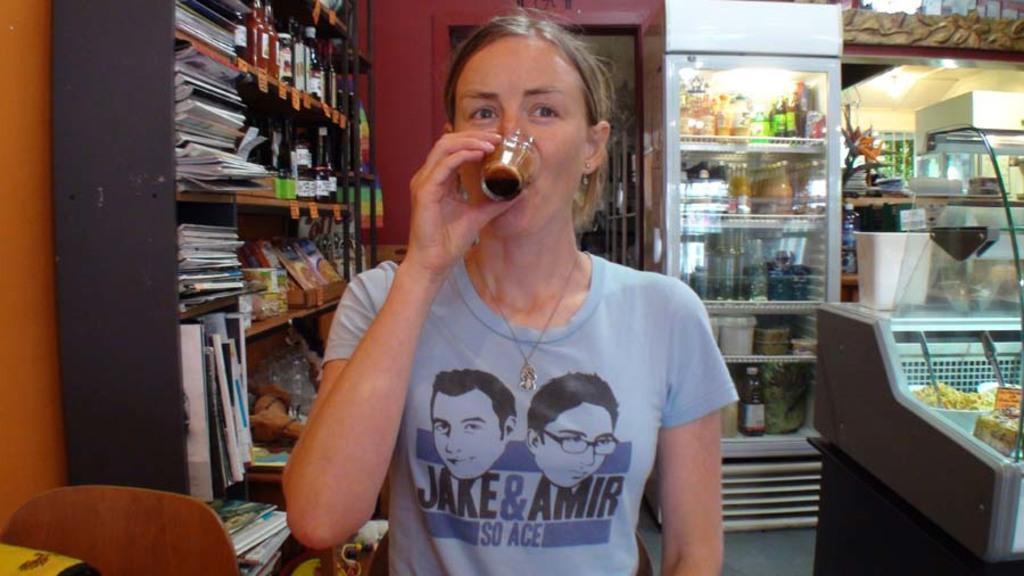How would you summarize this image in a sentence or two? In this picture there is a lady in the center of the image, she is drinking, here is a bookshelf on the left side of the image and there is a refrigerator and a glass container on the right side of the image. 